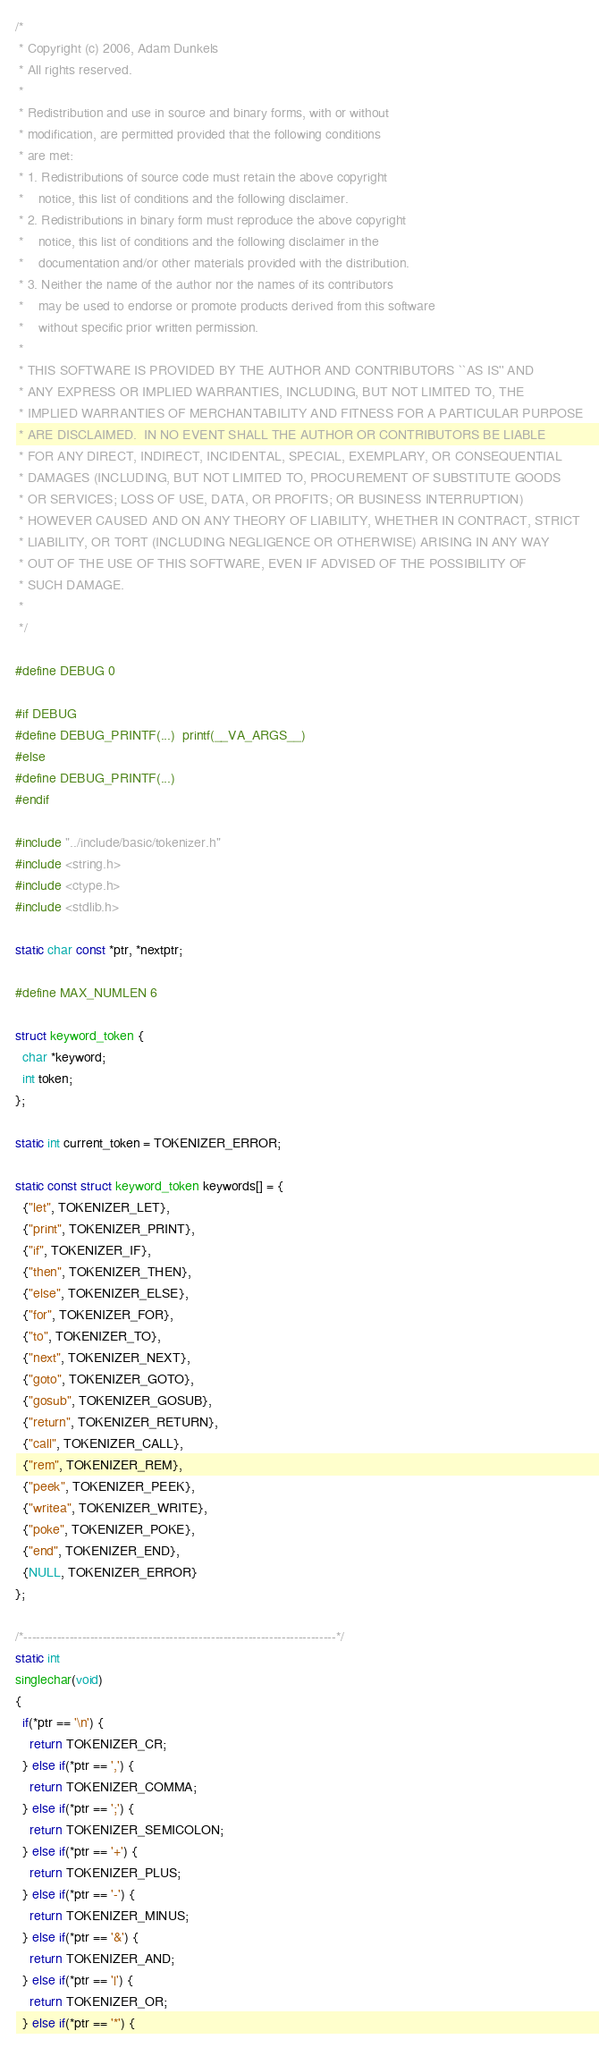Convert code to text. <code><loc_0><loc_0><loc_500><loc_500><_C_>/*
 * Copyright (c) 2006, Adam Dunkels
 * All rights reserved.
 *
 * Redistribution and use in source and binary forms, with or without
 * modification, are permitted provided that the following conditions
 * are met:
 * 1. Redistributions of source code must retain the above copyright
 *    notice, this list of conditions and the following disclaimer.
 * 2. Redistributions in binary form must reproduce the above copyright
 *    notice, this list of conditions and the following disclaimer in the
 *    documentation and/or other materials provided with the distribution.
 * 3. Neither the name of the author nor the names of its contributors
 *    may be used to endorse or promote products derived from this software
 *    without specific prior written permission.
 *
 * THIS SOFTWARE IS PROVIDED BY THE AUTHOR AND CONTRIBUTORS ``AS IS'' AND
 * ANY EXPRESS OR IMPLIED WARRANTIES, INCLUDING, BUT NOT LIMITED TO, THE
 * IMPLIED WARRANTIES OF MERCHANTABILITY AND FITNESS FOR A PARTICULAR PURPOSE
 * ARE DISCLAIMED.  IN NO EVENT SHALL THE AUTHOR OR CONTRIBUTORS BE LIABLE
 * FOR ANY DIRECT, INDIRECT, INCIDENTAL, SPECIAL, EXEMPLARY, OR CONSEQUENTIAL
 * DAMAGES (INCLUDING, BUT NOT LIMITED TO, PROCUREMENT OF SUBSTITUTE GOODS
 * OR SERVICES; LOSS OF USE, DATA, OR PROFITS; OR BUSINESS INTERRUPTION)
 * HOWEVER CAUSED AND ON ANY THEORY OF LIABILITY, WHETHER IN CONTRACT, STRICT
 * LIABILITY, OR TORT (INCLUDING NEGLIGENCE OR OTHERWISE) ARISING IN ANY WAY
 * OUT OF THE USE OF THIS SOFTWARE, EVEN IF ADVISED OF THE POSSIBILITY OF
 * SUCH DAMAGE.
 *
 */

#define DEBUG 0

#if DEBUG
#define DEBUG_PRINTF(...)  printf(__VA_ARGS__)
#else
#define DEBUG_PRINTF(...)
#endif

#include "../include/basic/tokenizer.h"
#include <string.h>
#include <ctype.h>
#include <stdlib.h>

static char const *ptr, *nextptr;

#define MAX_NUMLEN 6

struct keyword_token {
  char *keyword;
  int token;
};

static int current_token = TOKENIZER_ERROR;

static const struct keyword_token keywords[] = {
  {"let", TOKENIZER_LET},
  {"print", TOKENIZER_PRINT},
  {"if", TOKENIZER_IF},
  {"then", TOKENIZER_THEN},
  {"else", TOKENIZER_ELSE},
  {"for", TOKENIZER_FOR},
  {"to", TOKENIZER_TO},
  {"next", TOKENIZER_NEXT},
  {"goto", TOKENIZER_GOTO},
  {"gosub", TOKENIZER_GOSUB},
  {"return", TOKENIZER_RETURN},
  {"call", TOKENIZER_CALL},
  {"rem", TOKENIZER_REM},
  {"peek", TOKENIZER_PEEK},
  {"writea", TOKENIZER_WRITE},
  {"poke", TOKENIZER_POKE},
  {"end", TOKENIZER_END},
  {NULL, TOKENIZER_ERROR}
};

/*---------------------------------------------------------------------------*/
static int
singlechar(void)
{
  if(*ptr == '\n') {
    return TOKENIZER_CR;
  } else if(*ptr == ',') {
    return TOKENIZER_COMMA;
  } else if(*ptr == ';') {
    return TOKENIZER_SEMICOLON;
  } else if(*ptr == '+') {
    return TOKENIZER_PLUS;
  } else if(*ptr == '-') {
    return TOKENIZER_MINUS;
  } else if(*ptr == '&') {
    return TOKENIZER_AND;
  } else if(*ptr == '|') {
    return TOKENIZER_OR;
  } else if(*ptr == '*') {</code> 